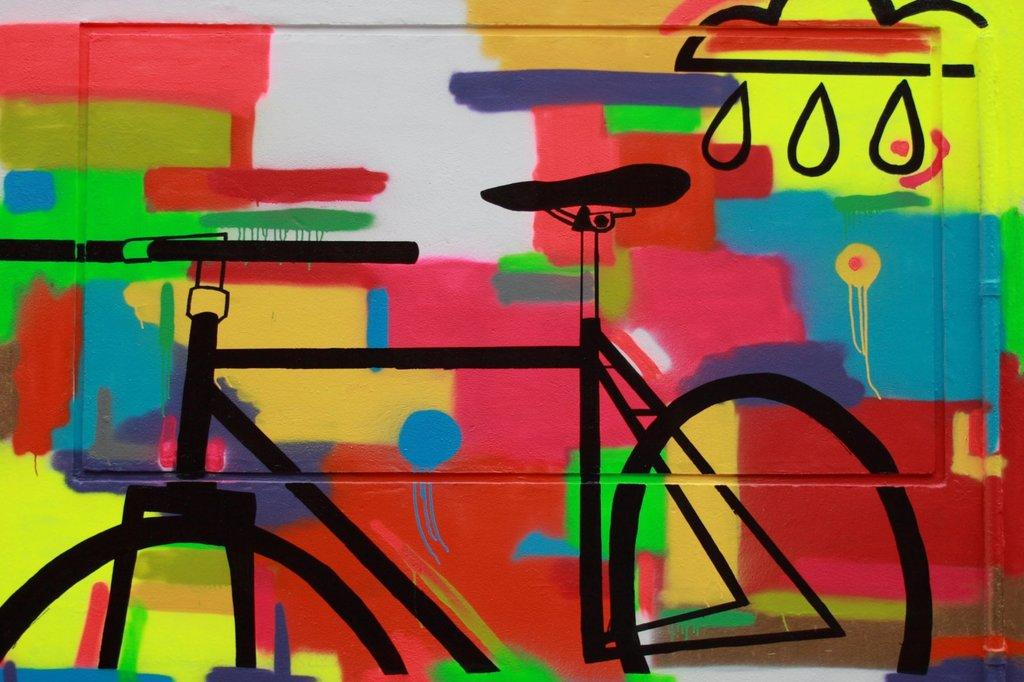What is on the wall in the image? There is a painting on the wall in the image. What is the subject of the painting? The painting is in the shape of a bicycle. How many giants are holding the bicycle in the painting? There are no giants present in the painting; it is a painting of a bicycle. What type of tool is being used to hammer the cattle in the painting? There is no tool or cattle present in the painting; it is a painting of a bicycle. 